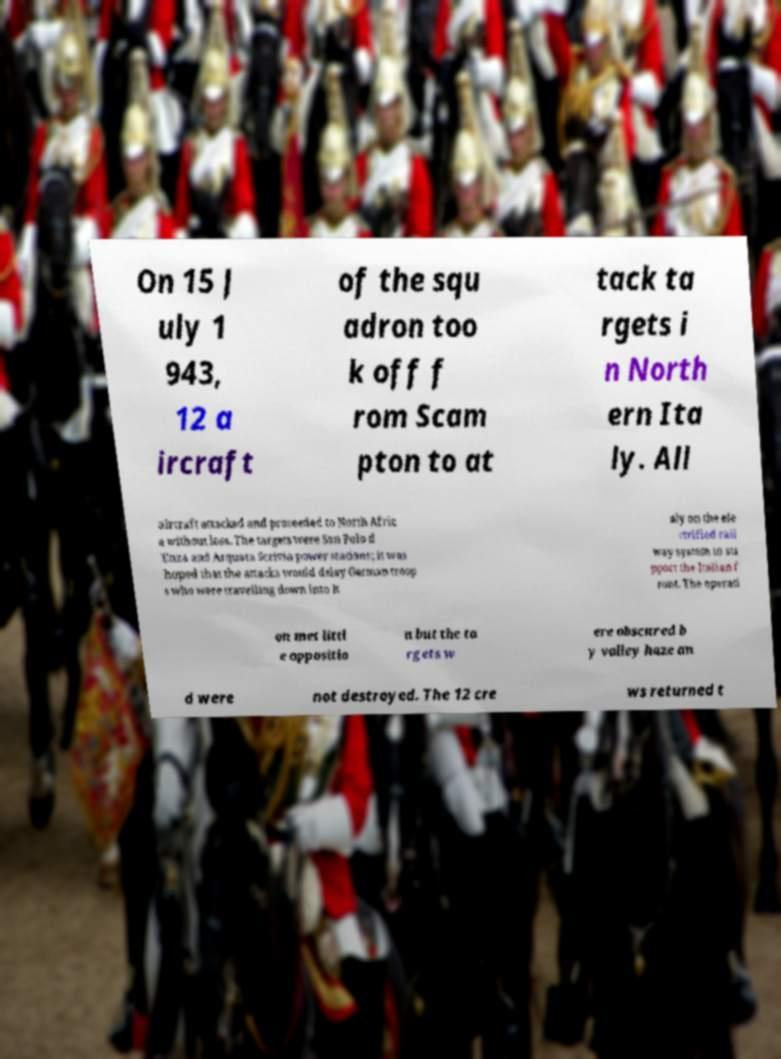For documentation purposes, I need the text within this image transcribed. Could you provide that? On 15 J uly 1 943, 12 a ircraft of the squ adron too k off f rom Scam pton to at tack ta rgets i n North ern Ita ly. All aircraft attacked and proceeded to North Afric a without loss. The targets were San Polo d 'Enza and Arquata Scrivia power stations; it was hoped that the attacks would delay German troop s who were travelling down into It aly on the ele ctrified rail way system to su pport the Italian f ront. The operati on met littl e oppositio n but the ta rgets w ere obscured b y valley haze an d were not destroyed. The 12 cre ws returned t 